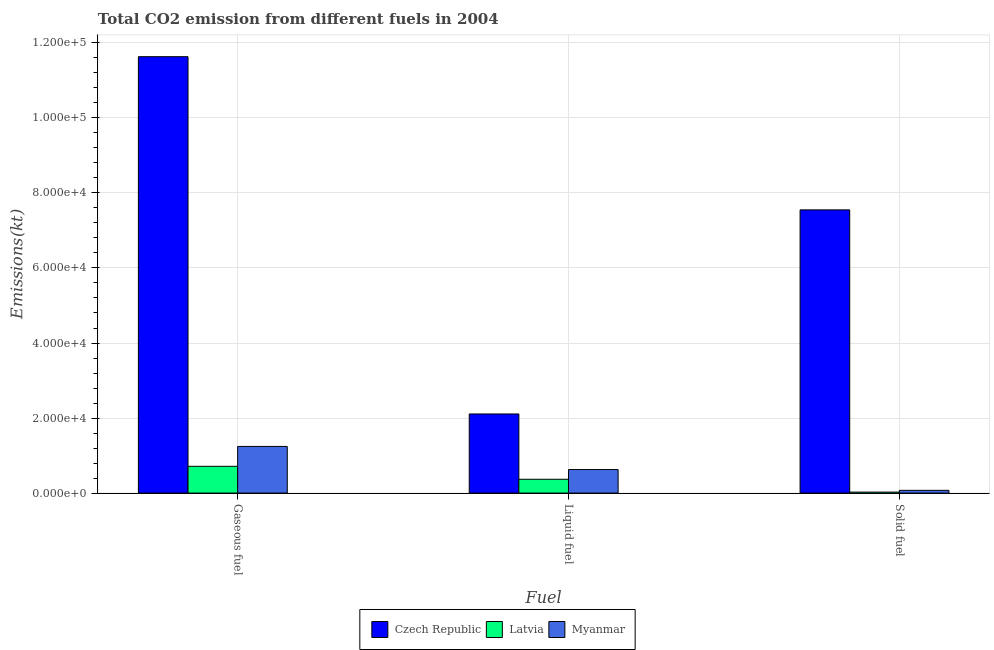How many different coloured bars are there?
Give a very brief answer. 3. How many bars are there on the 2nd tick from the right?
Your response must be concise. 3. What is the label of the 2nd group of bars from the left?
Offer a terse response. Liquid fuel. What is the amount of co2 emissions from gaseous fuel in Latvia?
Your response must be concise. 7132.31. Across all countries, what is the maximum amount of co2 emissions from gaseous fuel?
Keep it short and to the point. 1.16e+05. Across all countries, what is the minimum amount of co2 emissions from liquid fuel?
Your answer should be compact. 3678. In which country was the amount of co2 emissions from solid fuel maximum?
Give a very brief answer. Czech Republic. In which country was the amount of co2 emissions from solid fuel minimum?
Your answer should be very brief. Latvia. What is the total amount of co2 emissions from solid fuel in the graph?
Provide a succinct answer. 7.65e+04. What is the difference between the amount of co2 emissions from liquid fuel in Czech Republic and that in Latvia?
Provide a short and direct response. 1.74e+04. What is the difference between the amount of co2 emissions from liquid fuel in Latvia and the amount of co2 emissions from gaseous fuel in Czech Republic?
Give a very brief answer. -1.13e+05. What is the average amount of co2 emissions from solid fuel per country?
Your answer should be compact. 2.55e+04. What is the difference between the amount of co2 emissions from gaseous fuel and amount of co2 emissions from solid fuel in Myanmar?
Offer a terse response. 1.17e+04. In how many countries, is the amount of co2 emissions from liquid fuel greater than 40000 kt?
Your answer should be compact. 0. What is the ratio of the amount of co2 emissions from solid fuel in Czech Republic to that in Myanmar?
Provide a short and direct response. 103.44. What is the difference between the highest and the second highest amount of co2 emissions from solid fuel?
Offer a very short reply. 7.48e+04. What is the difference between the highest and the lowest amount of co2 emissions from solid fuel?
Ensure brevity in your answer.  7.52e+04. What does the 3rd bar from the left in Solid fuel represents?
Your answer should be compact. Myanmar. What does the 1st bar from the right in Solid fuel represents?
Provide a short and direct response. Myanmar. Is it the case that in every country, the sum of the amount of co2 emissions from gaseous fuel and amount of co2 emissions from liquid fuel is greater than the amount of co2 emissions from solid fuel?
Your answer should be very brief. Yes. How many countries are there in the graph?
Your answer should be very brief. 3. What is the difference between two consecutive major ticks on the Y-axis?
Ensure brevity in your answer.  2.00e+04. Are the values on the major ticks of Y-axis written in scientific E-notation?
Your answer should be very brief. Yes. Where does the legend appear in the graph?
Keep it short and to the point. Bottom center. How many legend labels are there?
Provide a short and direct response. 3. How are the legend labels stacked?
Make the answer very short. Horizontal. What is the title of the graph?
Provide a succinct answer. Total CO2 emission from different fuels in 2004. Does "Nigeria" appear as one of the legend labels in the graph?
Offer a very short reply. No. What is the label or title of the X-axis?
Provide a succinct answer. Fuel. What is the label or title of the Y-axis?
Give a very brief answer. Emissions(kt). What is the Emissions(kt) in Czech Republic in Gaseous fuel?
Keep it short and to the point. 1.16e+05. What is the Emissions(kt) in Latvia in Gaseous fuel?
Provide a short and direct response. 7132.31. What is the Emissions(kt) of Myanmar in Gaseous fuel?
Provide a succinct answer. 1.24e+04. What is the Emissions(kt) in Czech Republic in Liquid fuel?
Your response must be concise. 2.11e+04. What is the Emissions(kt) in Latvia in Liquid fuel?
Your answer should be compact. 3678. What is the Emissions(kt) of Myanmar in Liquid fuel?
Your answer should be compact. 6274.24. What is the Emissions(kt) in Czech Republic in Solid fuel?
Provide a short and direct response. 7.55e+04. What is the Emissions(kt) of Latvia in Solid fuel?
Offer a very short reply. 256.69. What is the Emissions(kt) in Myanmar in Solid fuel?
Provide a succinct answer. 729.73. Across all Fuel, what is the maximum Emissions(kt) of Czech Republic?
Offer a very short reply. 1.16e+05. Across all Fuel, what is the maximum Emissions(kt) in Latvia?
Offer a terse response. 7132.31. Across all Fuel, what is the maximum Emissions(kt) of Myanmar?
Your answer should be compact. 1.24e+04. Across all Fuel, what is the minimum Emissions(kt) of Czech Republic?
Keep it short and to the point. 2.11e+04. Across all Fuel, what is the minimum Emissions(kt) of Latvia?
Offer a terse response. 256.69. Across all Fuel, what is the minimum Emissions(kt) in Myanmar?
Give a very brief answer. 729.73. What is the total Emissions(kt) of Czech Republic in the graph?
Provide a succinct answer. 2.13e+05. What is the total Emissions(kt) of Latvia in the graph?
Your answer should be very brief. 1.11e+04. What is the total Emissions(kt) in Myanmar in the graph?
Make the answer very short. 1.94e+04. What is the difference between the Emissions(kt) in Czech Republic in Gaseous fuel and that in Liquid fuel?
Provide a succinct answer. 9.52e+04. What is the difference between the Emissions(kt) in Latvia in Gaseous fuel and that in Liquid fuel?
Your answer should be very brief. 3454.31. What is the difference between the Emissions(kt) in Myanmar in Gaseous fuel and that in Liquid fuel?
Make the answer very short. 6160.56. What is the difference between the Emissions(kt) of Czech Republic in Gaseous fuel and that in Solid fuel?
Provide a succinct answer. 4.08e+04. What is the difference between the Emissions(kt) of Latvia in Gaseous fuel and that in Solid fuel?
Your response must be concise. 6875.62. What is the difference between the Emissions(kt) of Myanmar in Gaseous fuel and that in Solid fuel?
Give a very brief answer. 1.17e+04. What is the difference between the Emissions(kt) of Czech Republic in Liquid fuel and that in Solid fuel?
Provide a short and direct response. -5.44e+04. What is the difference between the Emissions(kt) in Latvia in Liquid fuel and that in Solid fuel?
Your answer should be very brief. 3421.31. What is the difference between the Emissions(kt) in Myanmar in Liquid fuel and that in Solid fuel?
Offer a terse response. 5544.5. What is the difference between the Emissions(kt) in Czech Republic in Gaseous fuel and the Emissions(kt) in Latvia in Liquid fuel?
Provide a short and direct response. 1.13e+05. What is the difference between the Emissions(kt) in Czech Republic in Gaseous fuel and the Emissions(kt) in Myanmar in Liquid fuel?
Offer a terse response. 1.10e+05. What is the difference between the Emissions(kt) of Latvia in Gaseous fuel and the Emissions(kt) of Myanmar in Liquid fuel?
Offer a very short reply. 858.08. What is the difference between the Emissions(kt) in Czech Republic in Gaseous fuel and the Emissions(kt) in Latvia in Solid fuel?
Keep it short and to the point. 1.16e+05. What is the difference between the Emissions(kt) of Czech Republic in Gaseous fuel and the Emissions(kt) of Myanmar in Solid fuel?
Your answer should be compact. 1.16e+05. What is the difference between the Emissions(kt) of Latvia in Gaseous fuel and the Emissions(kt) of Myanmar in Solid fuel?
Offer a terse response. 6402.58. What is the difference between the Emissions(kt) in Czech Republic in Liquid fuel and the Emissions(kt) in Latvia in Solid fuel?
Ensure brevity in your answer.  2.08e+04. What is the difference between the Emissions(kt) of Czech Republic in Liquid fuel and the Emissions(kt) of Myanmar in Solid fuel?
Offer a very short reply. 2.04e+04. What is the difference between the Emissions(kt) of Latvia in Liquid fuel and the Emissions(kt) of Myanmar in Solid fuel?
Provide a succinct answer. 2948.27. What is the average Emissions(kt) of Czech Republic per Fuel?
Ensure brevity in your answer.  7.10e+04. What is the average Emissions(kt) in Latvia per Fuel?
Your response must be concise. 3689. What is the average Emissions(kt) in Myanmar per Fuel?
Keep it short and to the point. 6479.59. What is the difference between the Emissions(kt) in Czech Republic and Emissions(kt) in Latvia in Gaseous fuel?
Your answer should be very brief. 1.09e+05. What is the difference between the Emissions(kt) in Czech Republic and Emissions(kt) in Myanmar in Gaseous fuel?
Your answer should be very brief. 1.04e+05. What is the difference between the Emissions(kt) in Latvia and Emissions(kt) in Myanmar in Gaseous fuel?
Provide a short and direct response. -5302.48. What is the difference between the Emissions(kt) of Czech Republic and Emissions(kt) of Latvia in Liquid fuel?
Ensure brevity in your answer.  1.74e+04. What is the difference between the Emissions(kt) in Czech Republic and Emissions(kt) in Myanmar in Liquid fuel?
Give a very brief answer. 1.48e+04. What is the difference between the Emissions(kt) of Latvia and Emissions(kt) of Myanmar in Liquid fuel?
Give a very brief answer. -2596.24. What is the difference between the Emissions(kt) of Czech Republic and Emissions(kt) of Latvia in Solid fuel?
Your answer should be very brief. 7.52e+04. What is the difference between the Emissions(kt) of Czech Republic and Emissions(kt) of Myanmar in Solid fuel?
Ensure brevity in your answer.  7.48e+04. What is the difference between the Emissions(kt) in Latvia and Emissions(kt) in Myanmar in Solid fuel?
Keep it short and to the point. -473.04. What is the ratio of the Emissions(kt) of Czech Republic in Gaseous fuel to that in Liquid fuel?
Your answer should be compact. 5.52. What is the ratio of the Emissions(kt) in Latvia in Gaseous fuel to that in Liquid fuel?
Keep it short and to the point. 1.94. What is the ratio of the Emissions(kt) of Myanmar in Gaseous fuel to that in Liquid fuel?
Provide a short and direct response. 1.98. What is the ratio of the Emissions(kt) in Czech Republic in Gaseous fuel to that in Solid fuel?
Your answer should be compact. 1.54. What is the ratio of the Emissions(kt) of Latvia in Gaseous fuel to that in Solid fuel?
Provide a short and direct response. 27.79. What is the ratio of the Emissions(kt) of Myanmar in Gaseous fuel to that in Solid fuel?
Provide a short and direct response. 17.04. What is the ratio of the Emissions(kt) of Czech Republic in Liquid fuel to that in Solid fuel?
Offer a very short reply. 0.28. What is the ratio of the Emissions(kt) of Latvia in Liquid fuel to that in Solid fuel?
Give a very brief answer. 14.33. What is the ratio of the Emissions(kt) of Myanmar in Liquid fuel to that in Solid fuel?
Your response must be concise. 8.6. What is the difference between the highest and the second highest Emissions(kt) in Czech Republic?
Your answer should be compact. 4.08e+04. What is the difference between the highest and the second highest Emissions(kt) of Latvia?
Offer a terse response. 3454.31. What is the difference between the highest and the second highest Emissions(kt) of Myanmar?
Make the answer very short. 6160.56. What is the difference between the highest and the lowest Emissions(kt) in Czech Republic?
Make the answer very short. 9.52e+04. What is the difference between the highest and the lowest Emissions(kt) of Latvia?
Make the answer very short. 6875.62. What is the difference between the highest and the lowest Emissions(kt) of Myanmar?
Provide a succinct answer. 1.17e+04. 